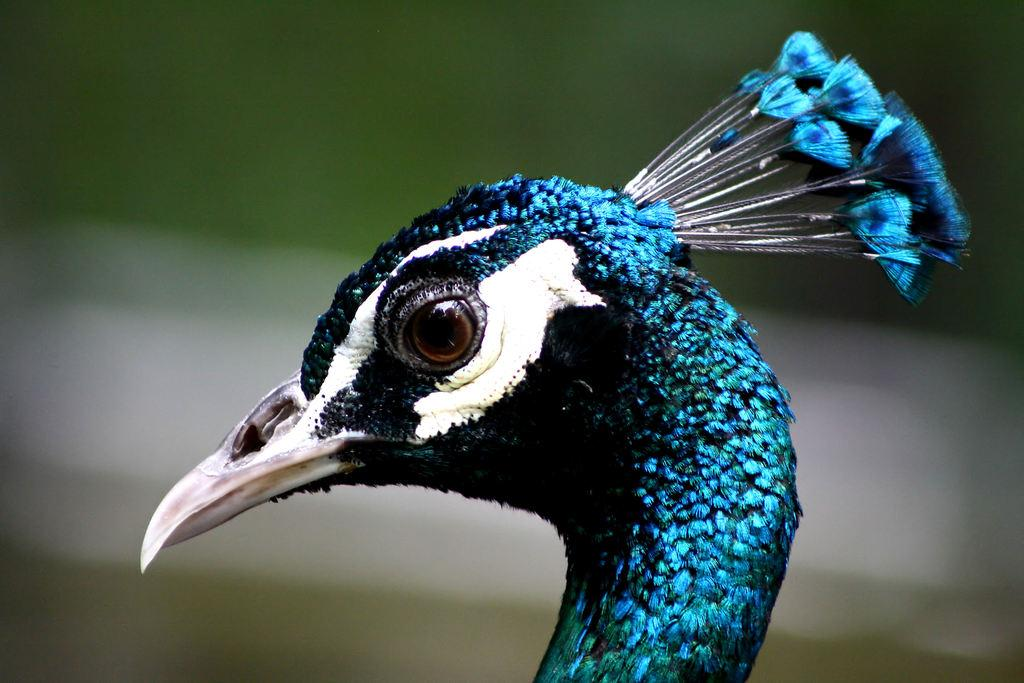What animal is the main subject of the image? There is a peacock in the image. In which direction is the peacock facing? The peacock is facing towards the left side. What distinguishing feature can be seen on the peacock's head? The peacock has a blue crest on its head. Can you describe the background of the image? The background of the image is blurred. What type of bubble is the peacock blowing in the image? There is no bubble present in the image; it features a peacock with a blue crest on its head. Does the peacock appear to have any regrets in the image? There is no indication of regret in the image, as it simply shows a peacock facing towards the left side with a blue crest on its head. 